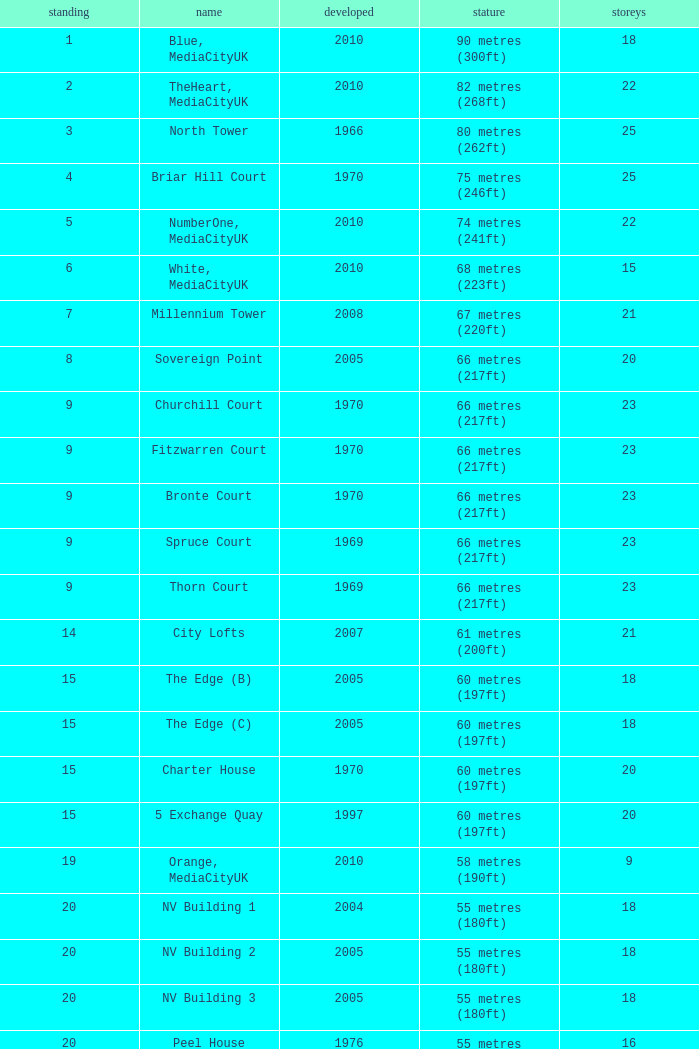What is the lowest Floors, when Built is greater than 1970, and when Name is NV Building 3? 18.0. 